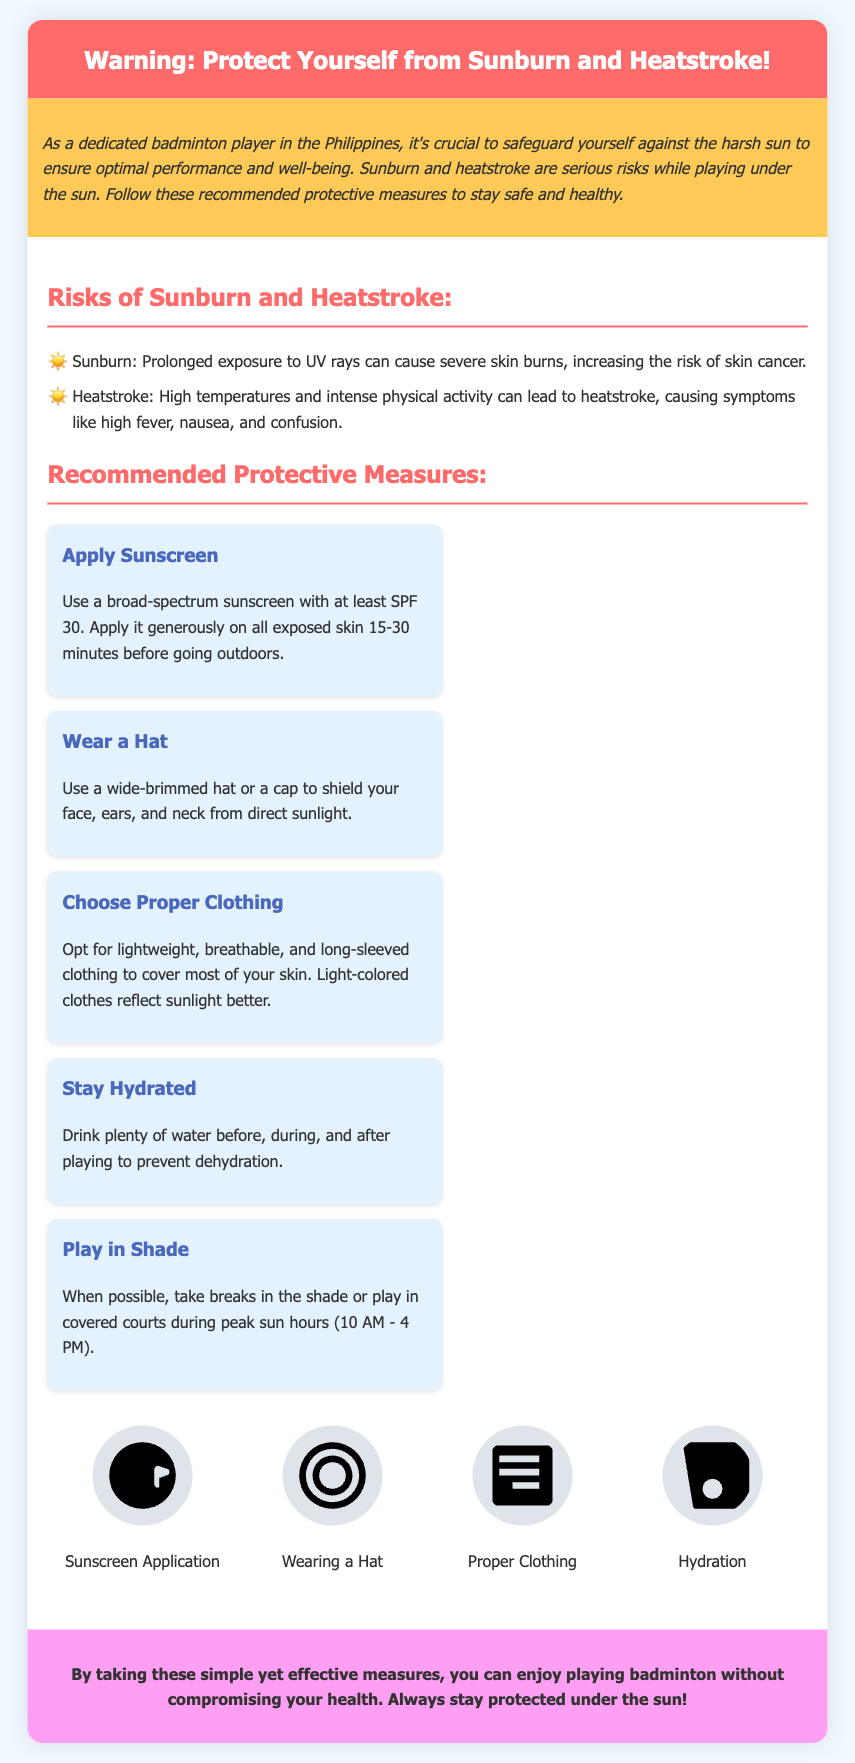what are the risks mentioned in the document? The document lists sunburn and heatstroke as risks associated with sun exposure.
Answer: sunburn and heatstroke what is the recommended SPF for sunscreen? The label specifies using a broad-spectrum sunscreen with at least SPF 30.
Answer: SPF 30 how many protective measures are recommended? The document outlines five protective measures that players should follow to stay safe in the sun.
Answer: five what does the illustration for hydration depict? The illustration for hydration shows a person drinking water, emphasizing the importance of staying hydrated.
Answer: drinking water what should players do to prevent heatstroke? Players are advised to drink plenty of water before, during, and after playing to prevent dehydration and heatstroke.
Answer: drink plenty of water what is the peak sun hours to avoid playing? The document advises avoiding playing during peak sun hours from 10 AM to 4 PM.
Answer: 10 AM - 4 PM what type of clothing is recommended? The document suggests wearing lightweight, breathable, and long-sleeved clothing for sun protection.
Answer: lightweight, breathable, long-sleeved how is sunscreen supposed to be applied? The label instructs to apply sunscreen generously on all exposed skin 15-30 minutes before going outdoors.
Answer: 15-30 minutes before going outdoors what color of clothing reflects sunlight better? The document indicates that light-colored clothes reflect sunlight better than dark colors.
Answer: light-colored 